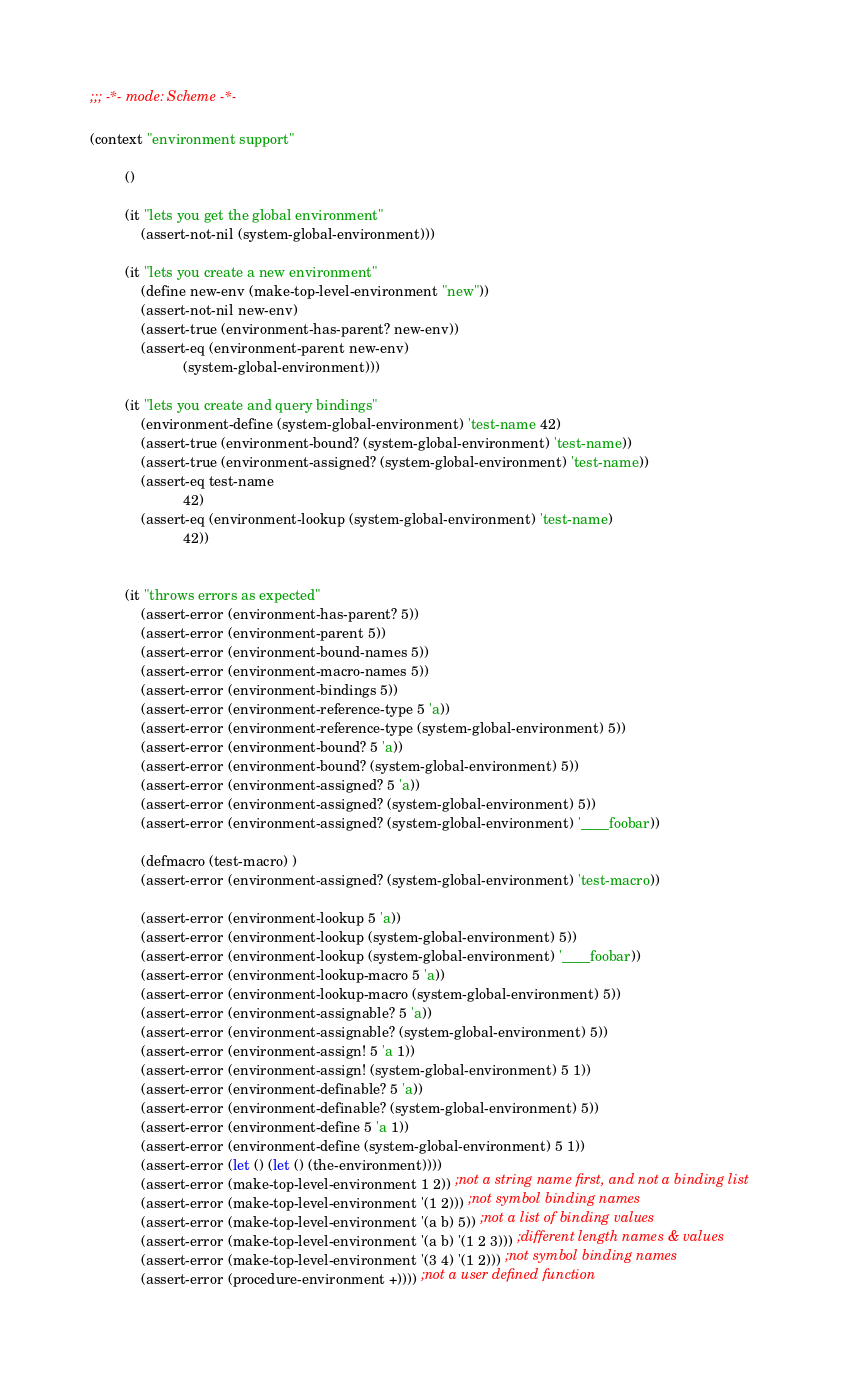Convert code to text. <code><loc_0><loc_0><loc_500><loc_500><_Lisp_>;;; -*- mode: Scheme -*-

(context "environment support"

         ()

         (it "lets you get the global environment"
             (assert-not-nil (system-global-environment)))

         (it "lets you create a new environment"
             (define new-env (make-top-level-environment "new"))
             (assert-not-nil new-env)
             (assert-true (environment-has-parent? new-env))
             (assert-eq (environment-parent new-env)
                        (system-global-environment)))

         (it "lets you create and query bindings"
             (environment-define (system-global-environment) 'test-name 42)
             (assert-true (environment-bound? (system-global-environment) 'test-name))
             (assert-true (environment-assigned? (system-global-environment) 'test-name))
             (assert-eq test-name
                        42)
             (assert-eq (environment-lookup (system-global-environment) 'test-name)
                        42))


         (it "throws errors as expected"
             (assert-error (environment-has-parent? 5))
             (assert-error (environment-parent 5))
             (assert-error (environment-bound-names 5))
             (assert-error (environment-macro-names 5))
             (assert-error (environment-bindings 5))
             (assert-error (environment-reference-type 5 'a))
             (assert-error (environment-reference-type (system-global-environment) 5))
             (assert-error (environment-bound? 5 'a))
             (assert-error (environment-bound? (system-global-environment) 5))
             (assert-error (environment-assigned? 5 'a))
             (assert-error (environment-assigned? (system-global-environment) 5))
             (assert-error (environment-assigned? (system-global-environment) '____foobar))

             (defmacro (test-macro) )
             (assert-error (environment-assigned? (system-global-environment) 'test-macro))

             (assert-error (environment-lookup 5 'a))
             (assert-error (environment-lookup (system-global-environment) 5))
             (assert-error (environment-lookup (system-global-environment) '____foobar))
             (assert-error (environment-lookup-macro 5 'a))
             (assert-error (environment-lookup-macro (system-global-environment) 5))
             (assert-error (environment-assignable? 5 'a))
             (assert-error (environment-assignable? (system-global-environment) 5))
             (assert-error (environment-assign! 5 'a 1))
             (assert-error (environment-assign! (system-global-environment) 5 1))
             (assert-error (environment-definable? 5 'a))
             (assert-error (environment-definable? (system-global-environment) 5))
             (assert-error (environment-define 5 'a 1))
             (assert-error (environment-define (system-global-environment) 5 1))
             (assert-error (let () (let () (the-environment))))
             (assert-error (make-top-level-environment 1 2)) ;not a string name first, and not a binding list
             (assert-error (make-top-level-environment '(1 2))) ;not symbol binding names
             (assert-error (make-top-level-environment '(a b) 5)) ;not a list of binding values
             (assert-error (make-top-level-environment '(a b) '(1 2 3))) ;different length names & values
             (assert-error (make-top-level-environment '(3 4) '(1 2))) ;not symbol binding names
             (assert-error (procedure-environment +)))) ;not a user defined function
</code> 